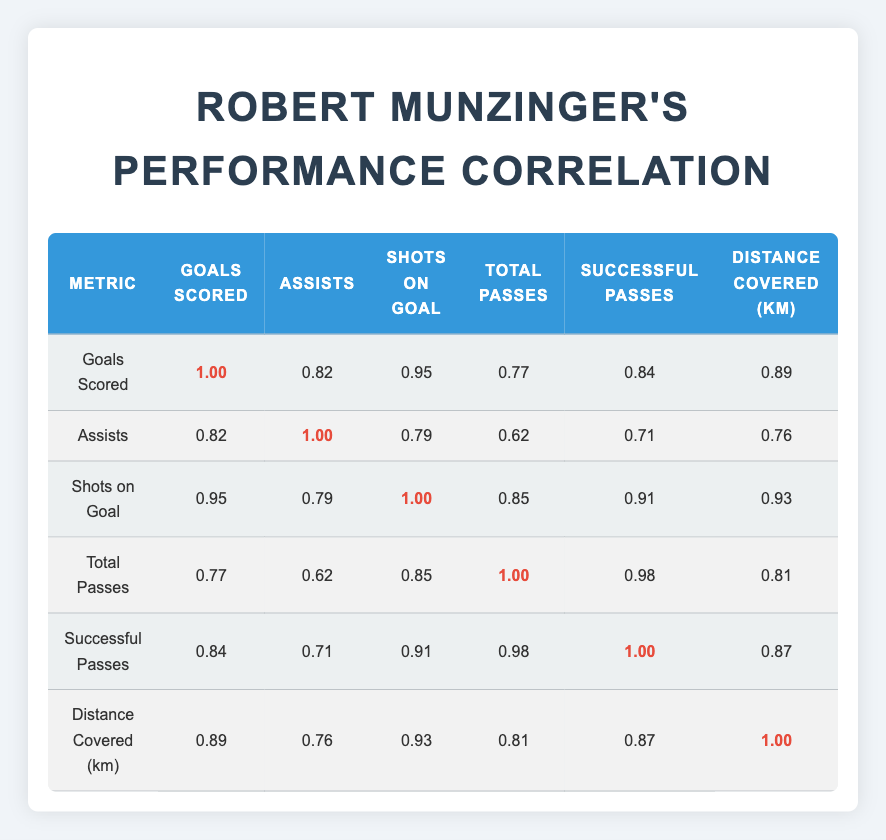What is the correlation between goals scored and assists? The table shows a correlation value of 0.82 between goals scored and assists. This indicates a strong positive relationship; as the number of goals scored increases, the number of assists tends to increase as well.
Answer: 0.82 Which match had the highest number of shots on goal? Among the matches listed, the highest number of shots on goal is 6, which occurred in the match against Team C on 2023-09-29.
Answer: Team C Did Robert Munzinger receive any red cards in his matches? Looking at the "red cards" column, it shows that he received 1 red card in the match against Team D on 2023-10-06, while all other matches had 0 red cards.
Answer: Yes What is the average distance covered in kilometers over all matches? To find the average distance covered, sum the distances: (10.5 + 8.2 + 12.1 + 7.0) = 37.8 km. There are 4 matches, so the average is 37.8/4 = 9.45 km.
Answer: 9.45 km What is the correlation value between successful passes and total passes? According to the correlation table, the correlation value between successful passes and total passes is 0.98, indicating a very strong positive relationship; as total passes increase, successful passes also tend to increase significantly.
Answer: 0.98 Which match had the lowest distance covered? The match with the lowest distance covered is against Team D on 2023-10-06, where he covered 7.0 kilometers.
Answer: Team D Is there a correlation upper limit in the table, and if so, what is it? The highest correlation value in the table is 1.00, which indicates a perfect positive correlation, meaning that two metrics move together perfectly, like goals scored and goals scored.
Answer: Yes, it is 1.00 How many assists did Robert Munzinger record in matches where he scored 2 or more goals? He scored 2 goals against Team A and had 1 assist; he scored 3 goals against Team C with 2 assists. So the total assists in matches with 2 or more goals is 1 + 2 = 3 assists in those matches.
Answer: 3 assists 